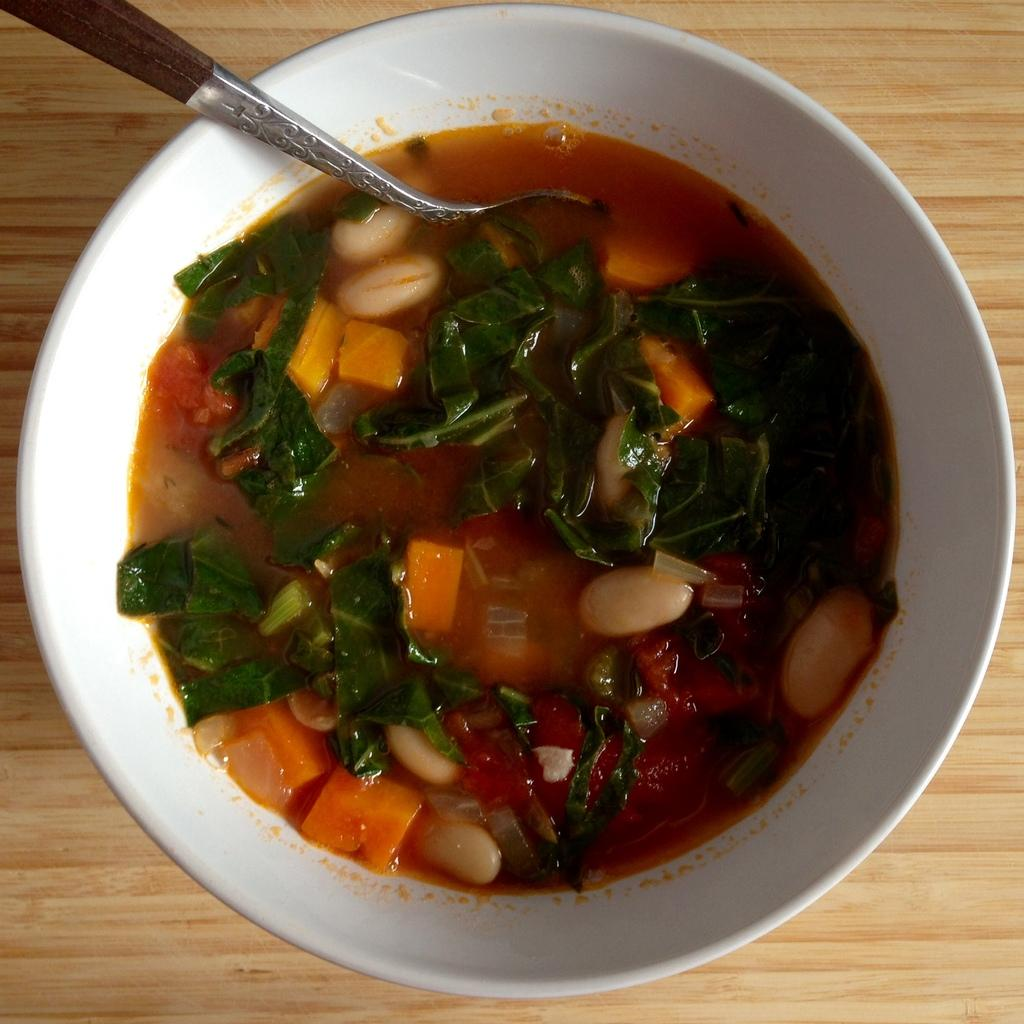What is in the bowl that is visible in the image? The bowl contains food. What utensil is present in the image? There is a spoon in the image. Where is the bowl located in the image? The bowl is placed on a table. What type of pot is the doctor using to create a quiet atmosphere in the image? There is no pot, doctor, or indication of a quiet atmosphere present in the image. 